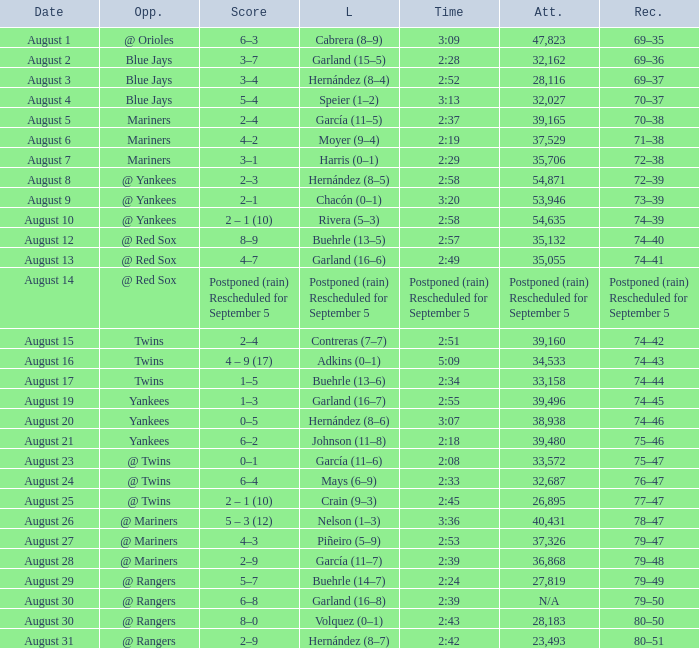Who was defeated with a duration of 2:42? Hernández (8–7). 